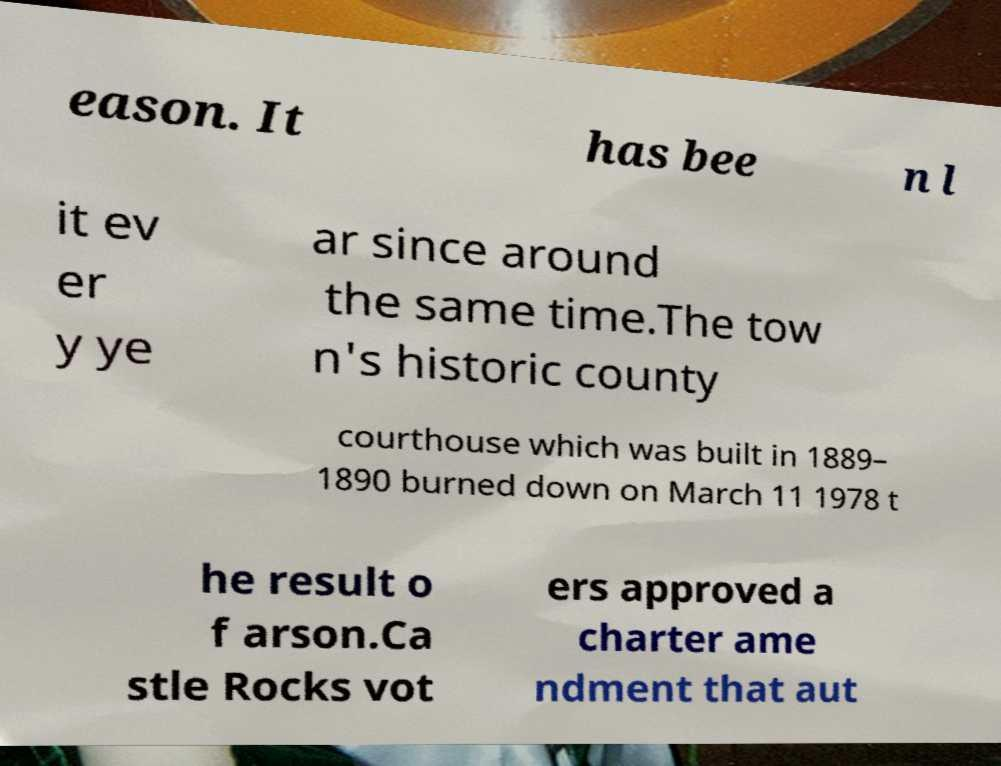Could you extract and type out the text from this image? eason. It has bee n l it ev er y ye ar since around the same time.The tow n's historic county courthouse which was built in 1889– 1890 burned down on March 11 1978 t he result o f arson.Ca stle Rocks vot ers approved a charter ame ndment that aut 